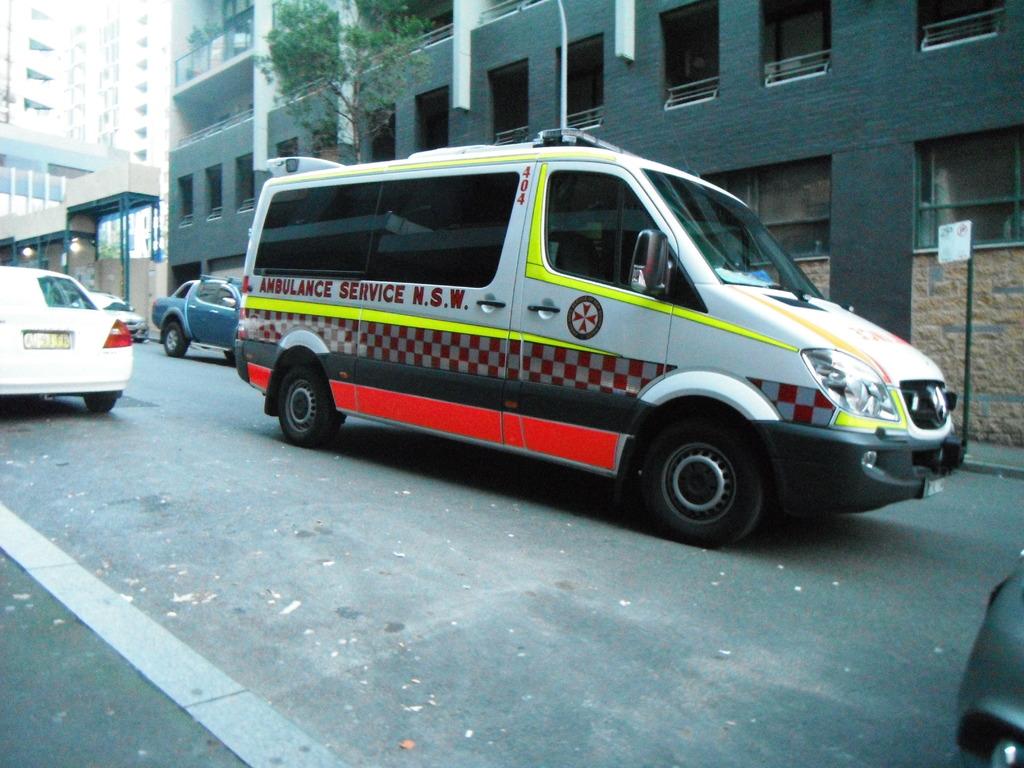What kind of emergency vehicle is the van?
Your answer should be compact. Ambulance. What is the number on the ambulance?
Provide a succinct answer. 404. 